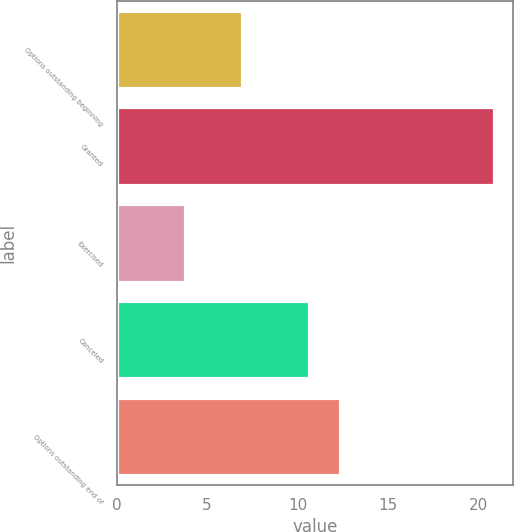<chart> <loc_0><loc_0><loc_500><loc_500><bar_chart><fcel>Options outstanding beginning<fcel>Granted<fcel>Exercised<fcel>Canceled<fcel>Options outstanding end of<nl><fcel>6.91<fcel>20.86<fcel>3.76<fcel>10.63<fcel>12.34<nl></chart> 